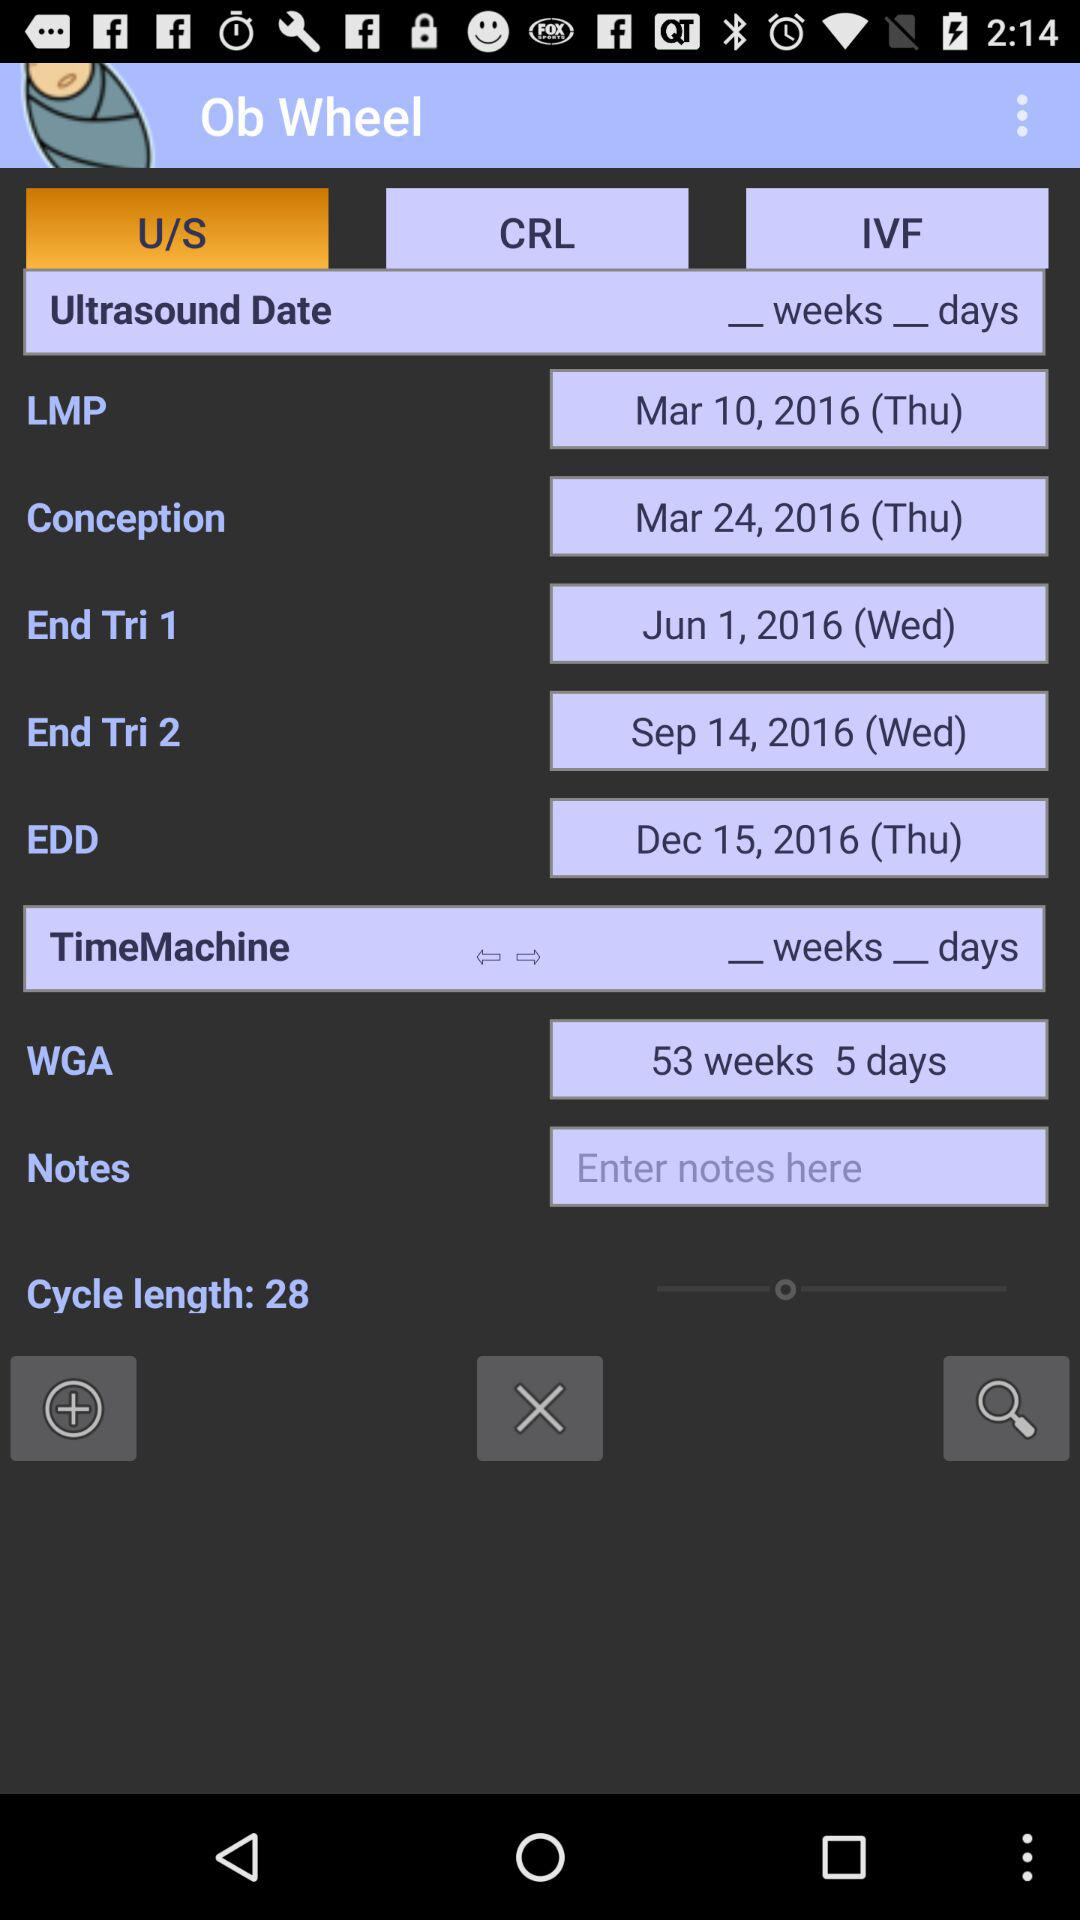What information does the 'Ob Wheel' display in this image? The 'Ob Wheel' displayed in the image provides pregnancy-related dates such as the last menstrual period (LMP), conception date, and estimated due date (EDD), among others. It's a tool used to track pregnancy milestones and predict dates for different stages of gestation. 